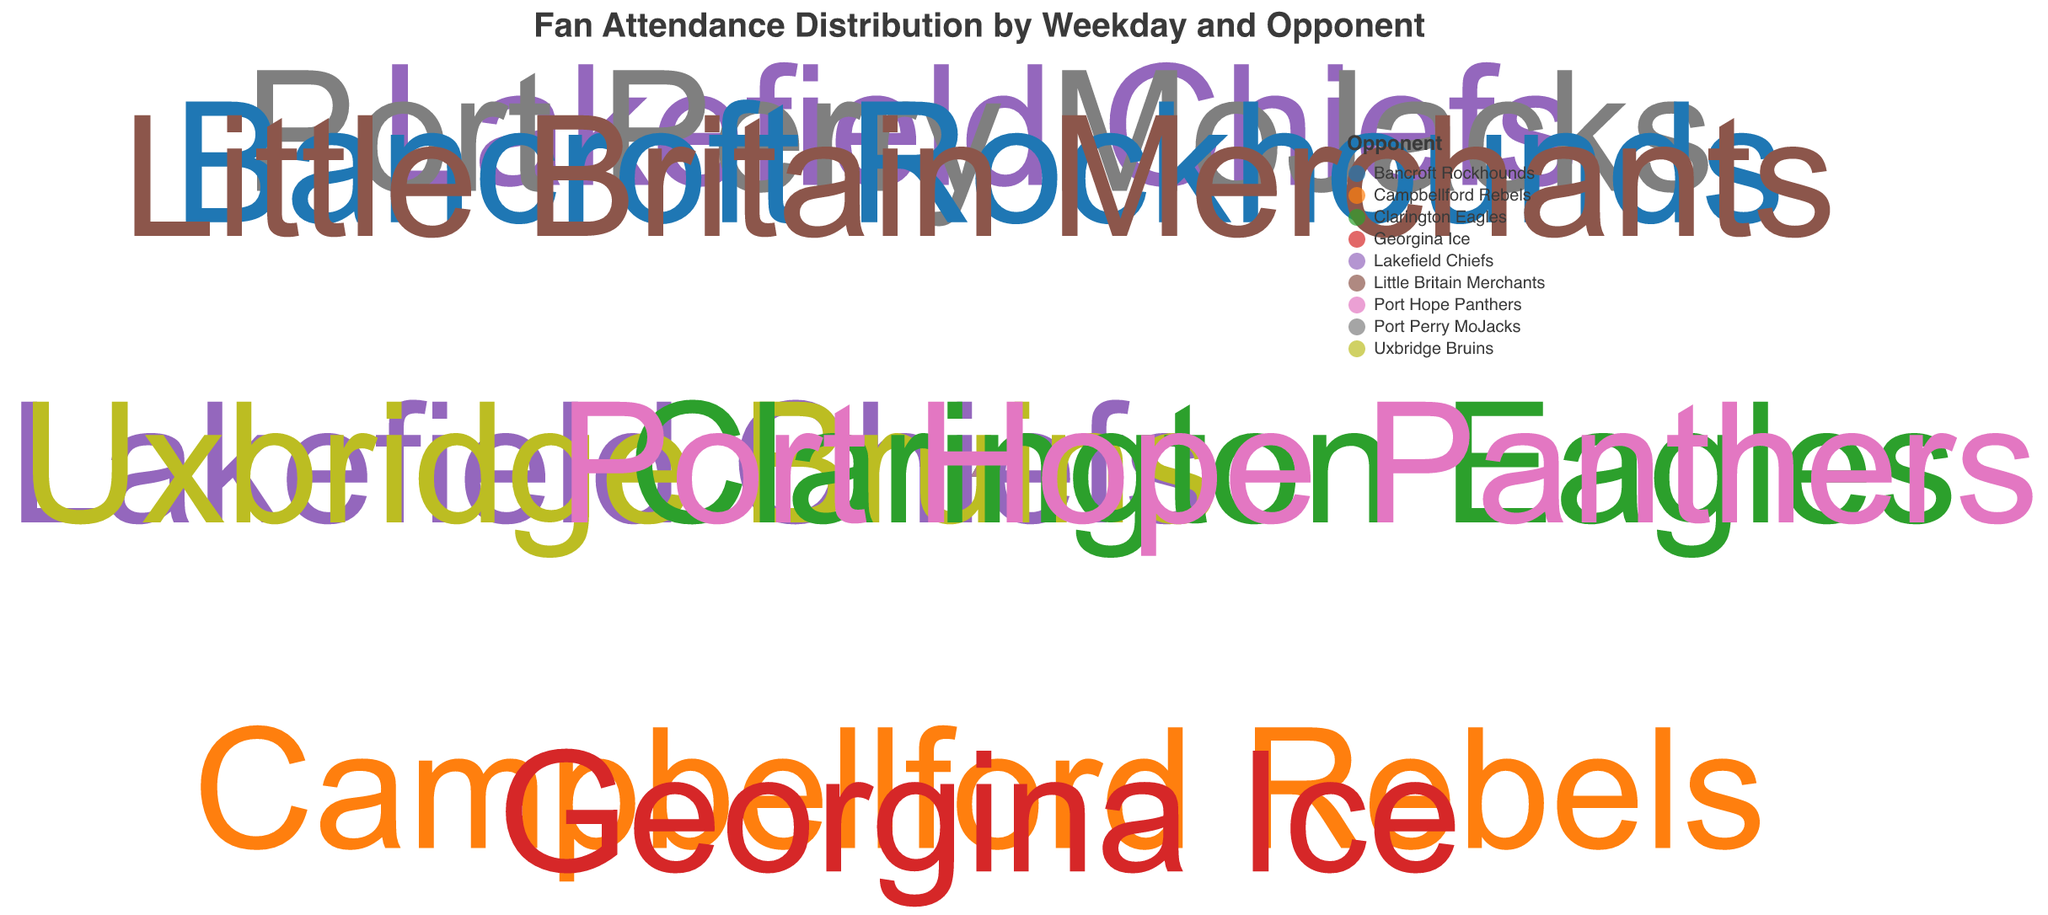What is the title of the chart? The title is usually placed at the top of a chart. It describes what the chart represents.
Answer: Fan Attendance Distribution by Weekday and Opponent On which weekday does the highest attendance occur? To find this, look at the radius (attendance) of each point and track which day has the largest radius.
Answer: Saturday Which opponent draws the highest fan attendance? Look for the opponent label on the plot that corresponds to the point with the maximum radius.
Answer: Lakefield Chiefs How many opponents are listed for Friday? Check the number of data points (triangles) associated with Friday and count them.
Answer: 2 What is the average attendance for games played on Sunday? Locate the data points for Sunday, then add their attendance values: 130 + 125. Divide by the number of points (2).
Answer: 127.5 Which day has the lowest recorded fan attendance? Identify the minimum radius (attendance) value and check which weekday it corresponds to.
Answer: Wednesday Compare the attendance for Friday's games. Which opponent had a higher turnout? Look at the two scatter points for Friday and compare their radii.
Answer: Georgina Ice Calculate the total attendance for Thursday's games. Sum the attendance values for the two Thursday points: 110 + 115.
Answer: 225 Which day appears more popular among fans, Wednesday or Thursday? Compare the radius of data points (attendance) for Wednesday and Thursday by adding them respectively and see which is greater. Wednesday: 100+90=190, Thursday: 110+115=225.
Answer: Thursday Is the attendance for games against the Bancroft Rockhounds higher or lower than the attendance against the Port Perry MoJacks? Compare the radius values for Bancroft Rockhounds (Wednesday) and Port Perry MoJacks (Sunday).
Answer: Lower 